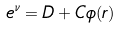Convert formula to latex. <formula><loc_0><loc_0><loc_500><loc_500>e ^ { \nu } = D + C \phi ( r )</formula> 